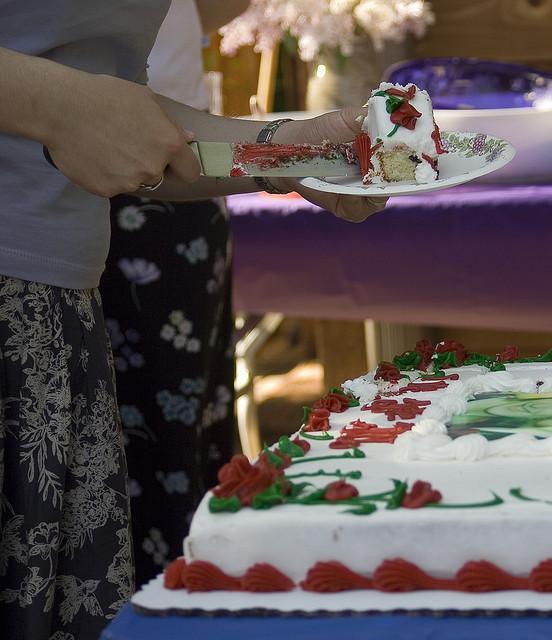How many cakes are there?
Give a very brief answer. 2. How many dining tables are in the photo?
Give a very brief answer. 2. 